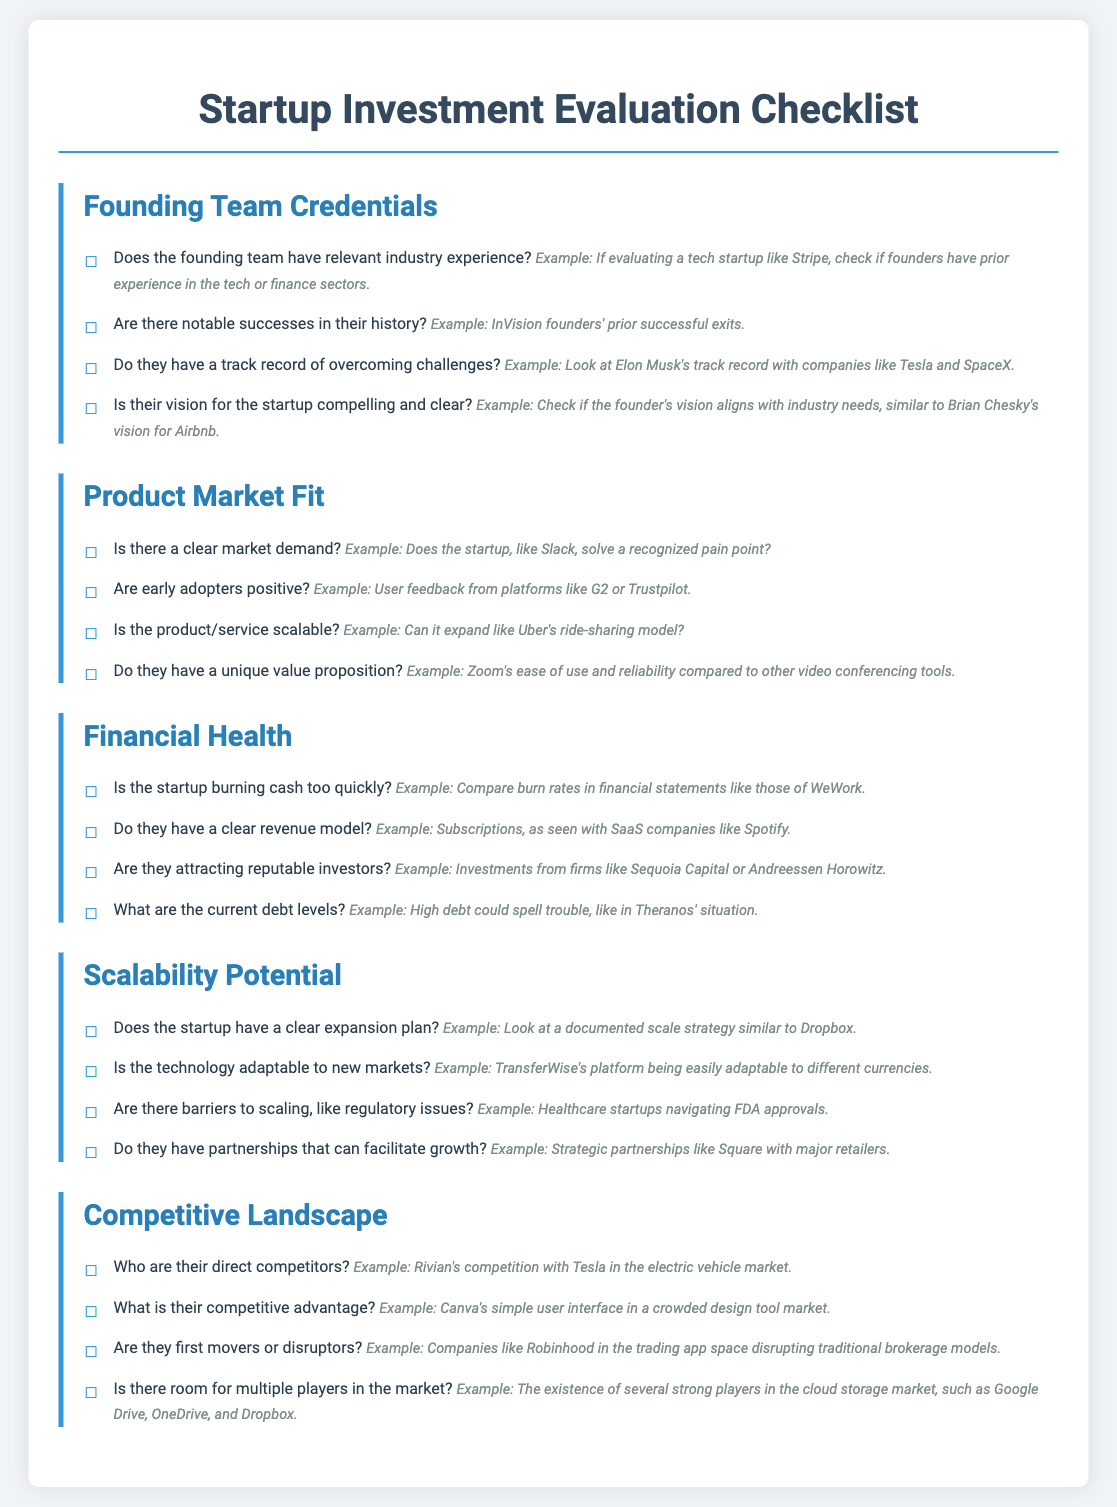What is the first evaluative category listed? The first category in the checklist for evaluating startup investments is "Founding Team Credentials."
Answer: Founding Team Credentials What is an example of a notable success in the founding team's history? The document mentions that InVision founders had prior successful exits as an example of a notable success.
Answer: InVision founders' prior successful exits What specific attribute of a product does the checklist associate with early adopters? The checklist states that early adopters must provide positive feedback for the product/service.
Answer: Positive feedback What is the example given for a unique value proposition? The checklist cites Zoom's ease of use and reliability compared to other video conferencing tools as an example.
Answer: Zoom's ease of use and reliability What is mentioned as a potential issue if a startup has high debt levels? The document states high debt could spell trouble, referencing Theranos' situation as an example.
Answer: Troubling What example is provided for a documented scale strategy? According to the checklist, Dropbox is provided as an example of a documented scale strategy.
Answer: Dropbox Who is mentioned as a direct competitor of Rivian? The checklist states that Rivian's competition is with Tesla in the electric vehicle market.
Answer: Tesla What type of model is highlighted as a revenue model for startups? The checklist identifies subscriptions, particularly in SaaS companies like Spotify, as a revenue model.
Answer: Subscriptions Are there barriers to scaling mentioned in the checklist? The checklist states that regulatory issues can act as barriers to scaling, which is a challenge for healthcare startups.
Answer: Regulatory issues 